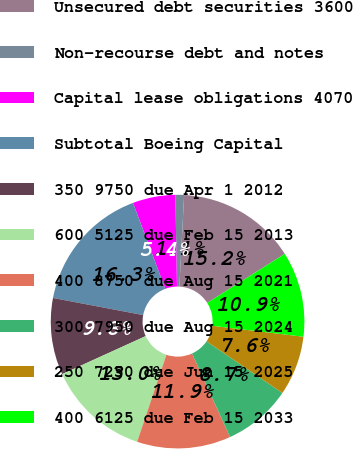<chart> <loc_0><loc_0><loc_500><loc_500><pie_chart><fcel>Unsecured debt securities 3600<fcel>Non-recourse debt and notes<fcel>Capital lease obligations 4070<fcel>Subtotal Boeing Capital<fcel>350 9750 due Apr 1 2012<fcel>600 5125 due Feb 15 2013<fcel>400 8750 due Aug 15 2021<fcel>300 7950 due Aug 15 2024<fcel>250 7250 due Jun 15 2025<fcel>400 6125 due Feb 15 2033<nl><fcel>15.21%<fcel>1.1%<fcel>5.44%<fcel>16.3%<fcel>9.78%<fcel>13.04%<fcel>11.95%<fcel>8.7%<fcel>7.61%<fcel>10.87%<nl></chart> 